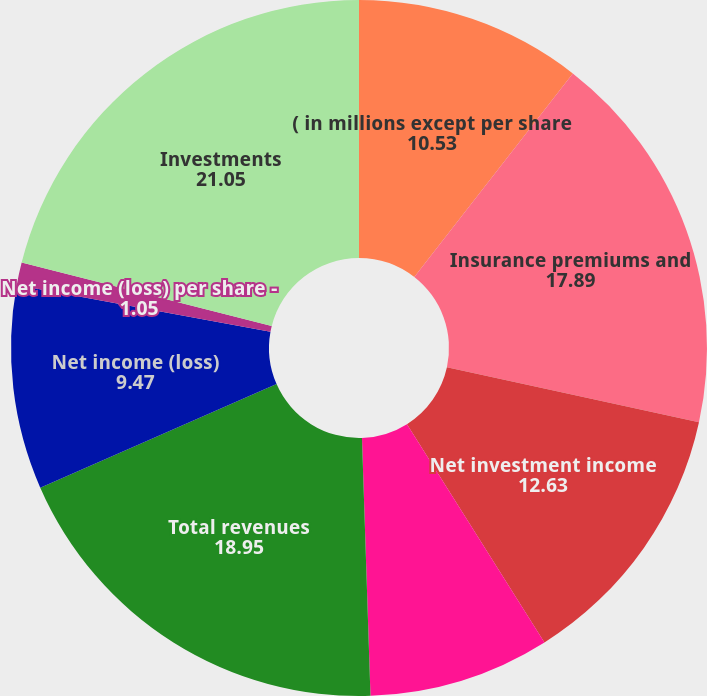Convert chart. <chart><loc_0><loc_0><loc_500><loc_500><pie_chart><fcel>( in millions except per share<fcel>Insurance premiums and<fcel>Net investment income<fcel>Realized capital gains and<fcel>Total revenues<fcel>Net income (loss)<fcel>Net income (loss) per share -<fcel>Cash dividends declared per<fcel>Investments<nl><fcel>10.53%<fcel>17.89%<fcel>12.63%<fcel>8.42%<fcel>18.95%<fcel>9.47%<fcel>1.05%<fcel>0.0%<fcel>21.05%<nl></chart> 